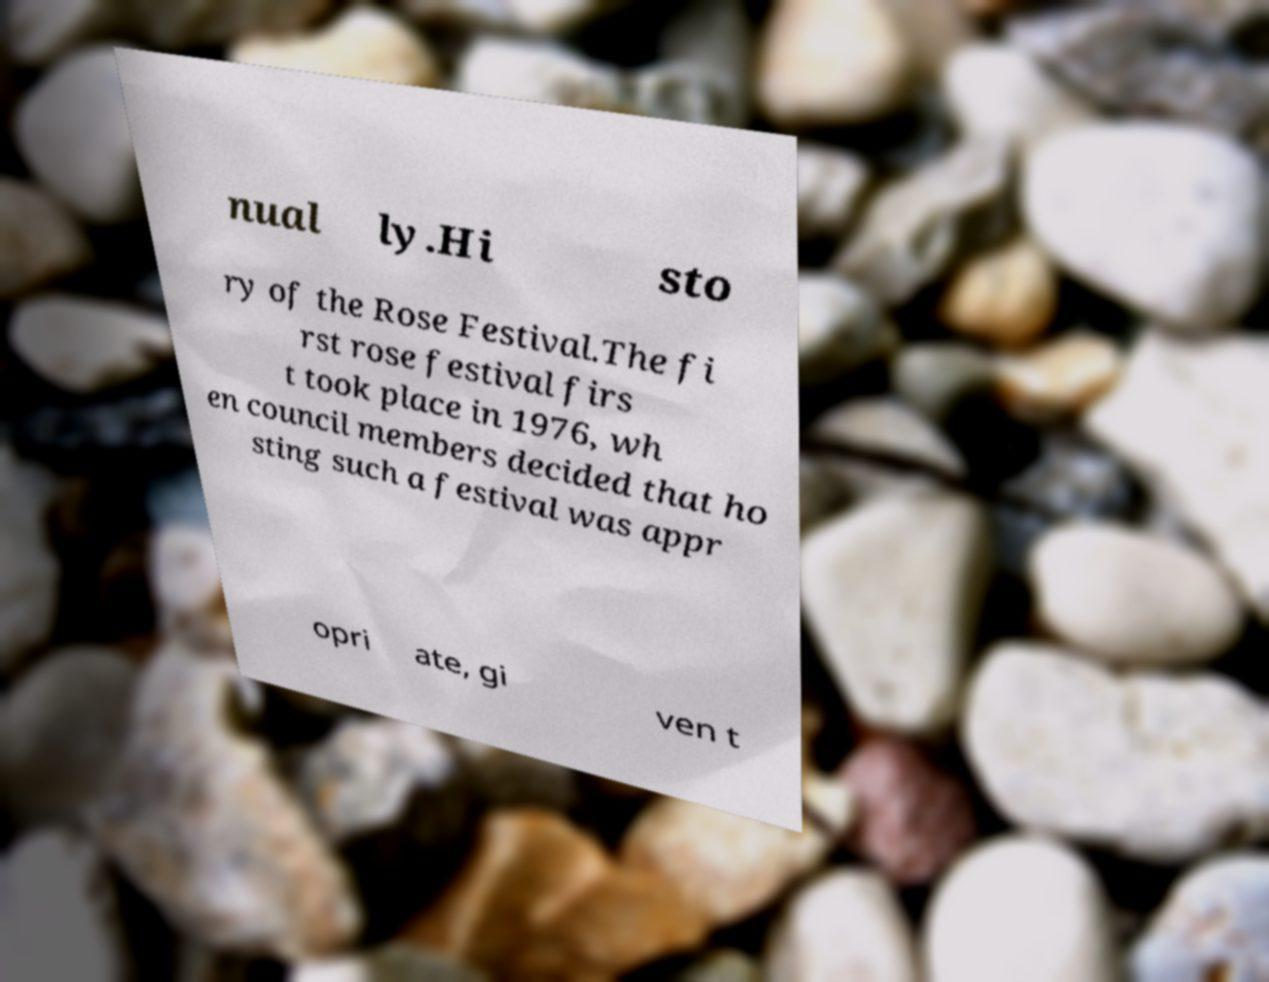Please read and relay the text visible in this image. What does it say? nual ly.Hi sto ry of the Rose Festival.The fi rst rose festival firs t took place in 1976, wh en council members decided that ho sting such a festival was appr opri ate, gi ven t 